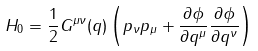<formula> <loc_0><loc_0><loc_500><loc_500>H _ { 0 } = \frac { 1 } { 2 } G ^ { \mu \nu } ( q ) \left ( p _ { \nu } p _ { \mu } + \frac { \partial \phi } { \partial q ^ { \mu } } \frac { \partial \phi } { \partial q ^ { \nu } } \right )</formula> 